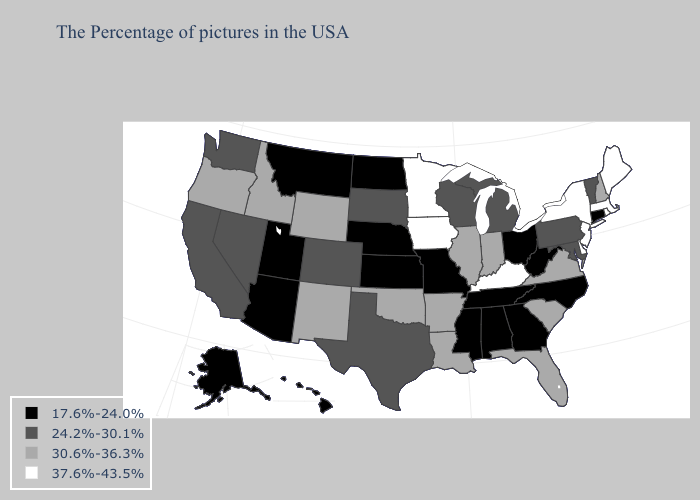Name the states that have a value in the range 17.6%-24.0%?
Keep it brief. Connecticut, North Carolina, West Virginia, Ohio, Georgia, Alabama, Tennessee, Mississippi, Missouri, Kansas, Nebraska, North Dakota, Utah, Montana, Arizona, Alaska, Hawaii. What is the lowest value in states that border Montana?
Answer briefly. 17.6%-24.0%. What is the highest value in the West ?
Quick response, please. 30.6%-36.3%. Name the states that have a value in the range 30.6%-36.3%?
Concise answer only. New Hampshire, Virginia, South Carolina, Florida, Indiana, Illinois, Louisiana, Arkansas, Oklahoma, Wyoming, New Mexico, Idaho, Oregon. Does Kansas have the same value as Tennessee?
Give a very brief answer. Yes. What is the value of Idaho?
Be succinct. 30.6%-36.3%. How many symbols are there in the legend?
Write a very short answer. 4. What is the value of Oklahoma?
Be succinct. 30.6%-36.3%. What is the value of Texas?
Concise answer only. 24.2%-30.1%. Does Kentucky have the highest value in the USA?
Answer briefly. Yes. What is the value of North Carolina?
Quick response, please. 17.6%-24.0%. Name the states that have a value in the range 37.6%-43.5%?
Short answer required. Maine, Massachusetts, Rhode Island, New York, New Jersey, Delaware, Kentucky, Minnesota, Iowa. What is the value of Washington?
Write a very short answer. 24.2%-30.1%. Does Virginia have the same value as Alabama?
Write a very short answer. No. What is the value of South Carolina?
Give a very brief answer. 30.6%-36.3%. 